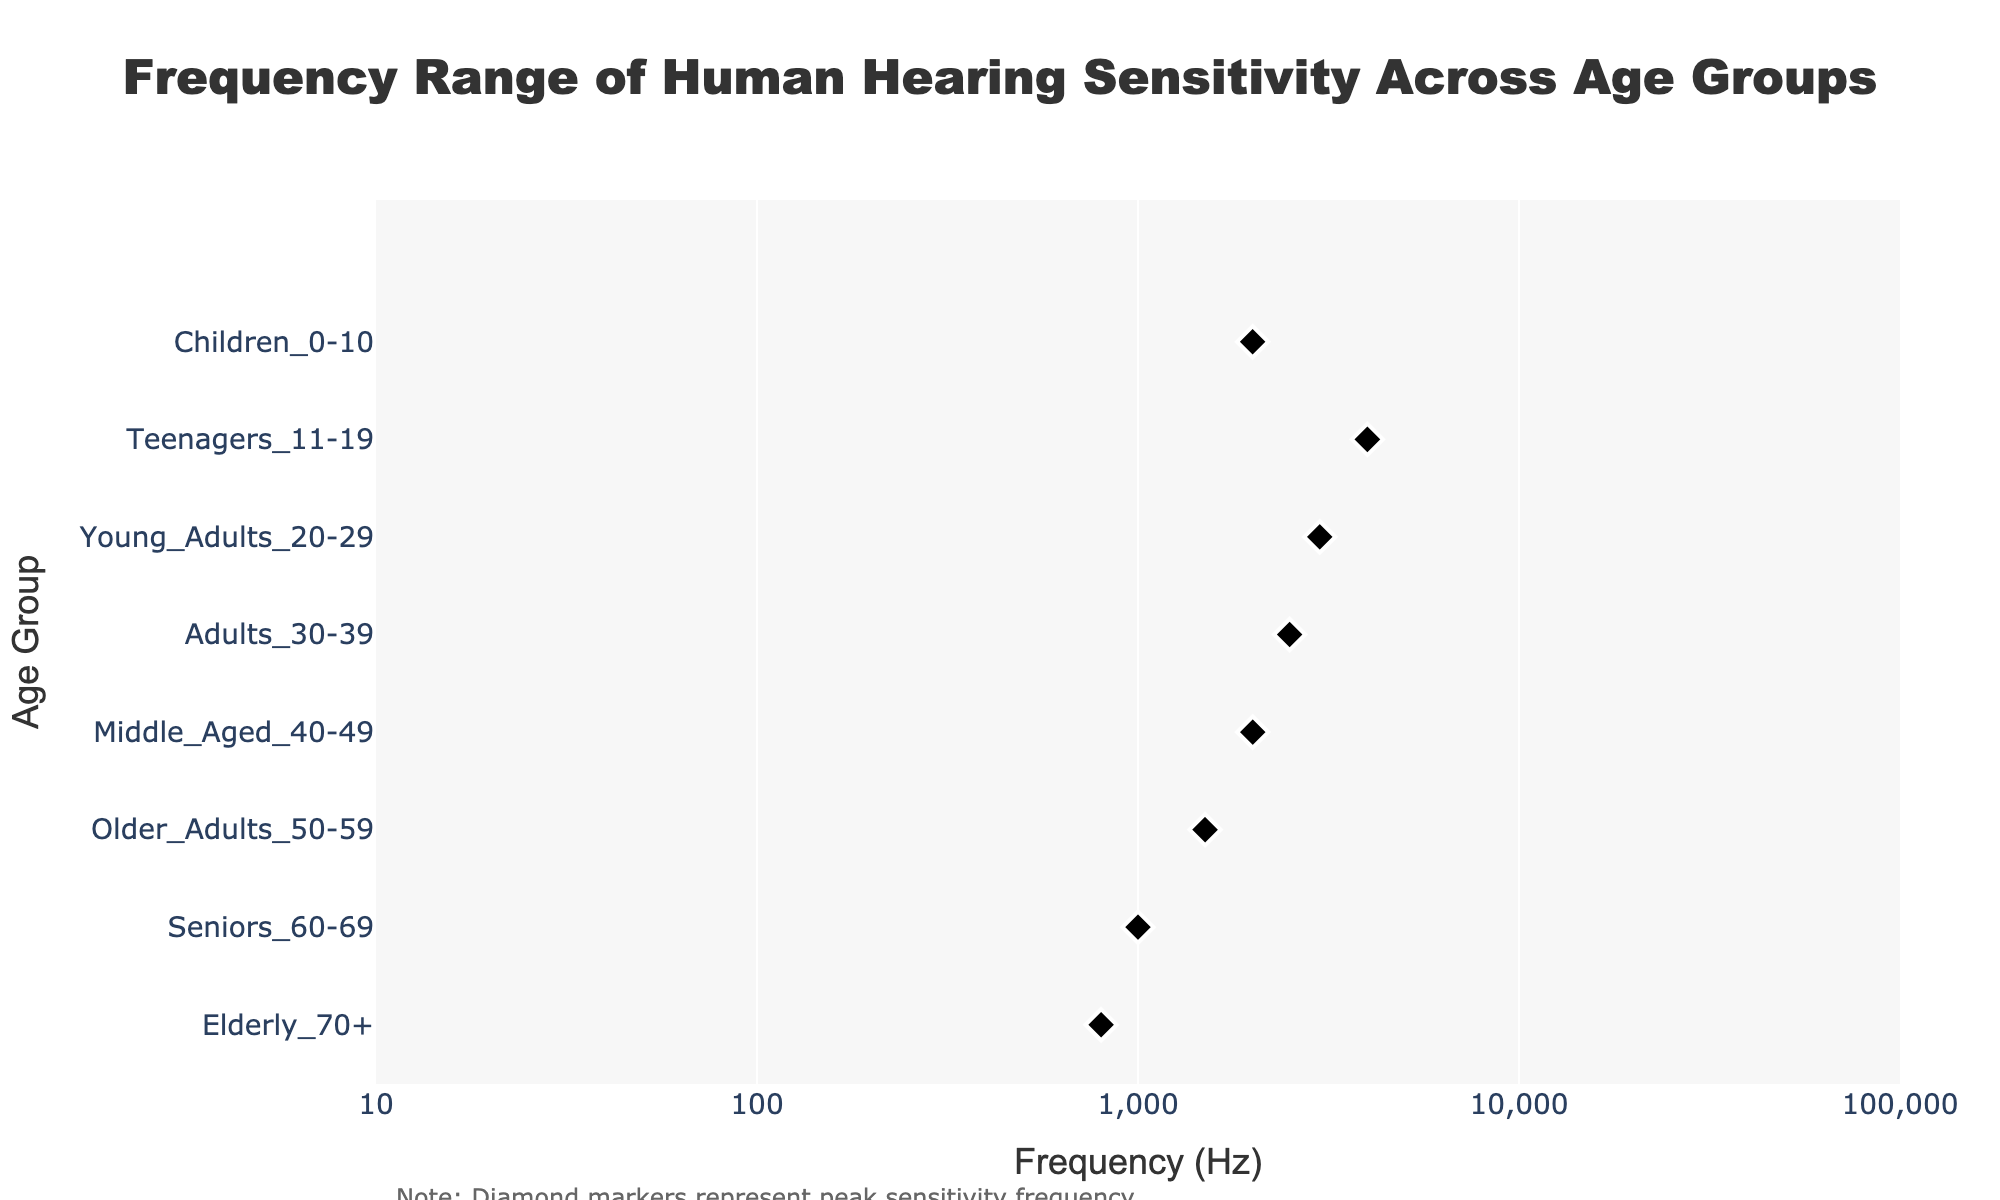How does the frequency range of hearing sensitivity vary across different age groups? To answer this, look at the horizontal density plots for each age group from left (lower frequencies) to right (higher frequencies) and note the start and end points of each plot.
Answer: The frequency range decreases with age; Children 0-10 have the widest range (20-20000 Hz) while the Elderly 70+ have the narrowest range (200-8000 Hz) What is the title of the figure? The title is usually found at the top of the figure, formatted in a larger font.
Answer: Frequency Range of Human Hearing Sensitivity Across Age Groups Which age group has the lowest peak sensitivity frequency? Check the diamond markers on the plots and see which one is positioned closest to the left side of the x-axis.
Answer: Elderly 70+ Which age group has the highest peak sensitivity frequency? Check the diamond markers on the plots and see which one is positioned closest to the right side of the x-axis.
Answer: Teenagers 11-19 How does the peak sensitivity frequency change from Young Adults 20-29 to Middle-Aged 40-49? Track the diamond markers for Young Adults 20-29 and Middle-Aged 40-49 and note their positions on the x-axis, then compare the two.
Answer: The peak frequency decreases from 3000 Hz to 2000 Hz What is the color pattern for representing each age group? Observe the shades or tints applied in each density plot to see if there is a noticeable color pattern.
Answer: Different colors (shades) are used for each age group How does the peak sensitivity frequency of Middle-Aged 40-49 compare to Older Adults 50-59? Locate the diamond markers for Middle-Aged 40-49 and Older Adults 50-59, then compare their positions on the x-axis.
Answer: Middle-Aged 40-49 have a higher peak sensitivity frequency (2000 Hz) than Older Adults 50-59 (1500 Hz) What happens to the lower frequency sensitivity as the age group increases from Young Adults 20-29 to Seniors 60-69? Observe the lower bounds of the density plots starting from Young Adults 20-29 up to Seniors 60-69, noting their positions on the x-axis.
Answer: It increases from 20 Hz to 100 Hz In terms of frequency range, which age group has the closest peak sensitivity to their lower frequency limit? Compare each group's diamond marker location with their respective plot's lower frequency limit.
Answer: Elderly 70+ (200 Hz lower limit and 800 Hz peak) Which age group has the widest frequency range? Observe the horizontal extents of each density plot and note the one that stretches the most.
Answer: Children 0-10 (20-20000 Hz) 